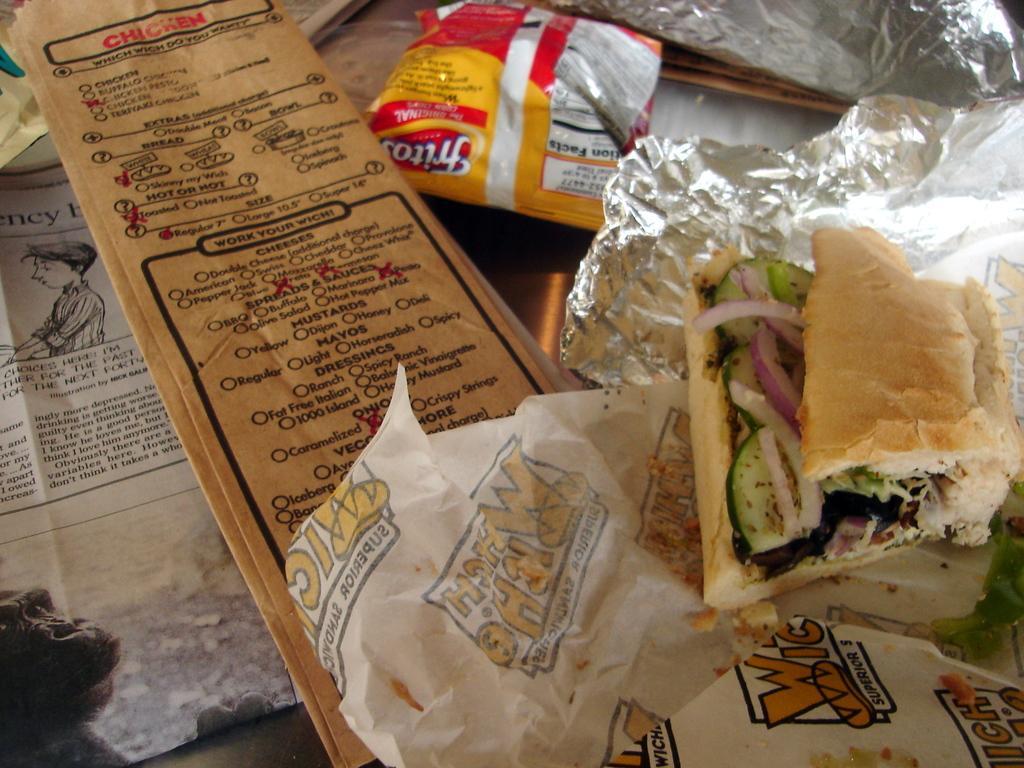Can you describe this image briefly? In this image I can see a food on the silver foil. I can see a yellow,red,brown colors covers and the paper. 